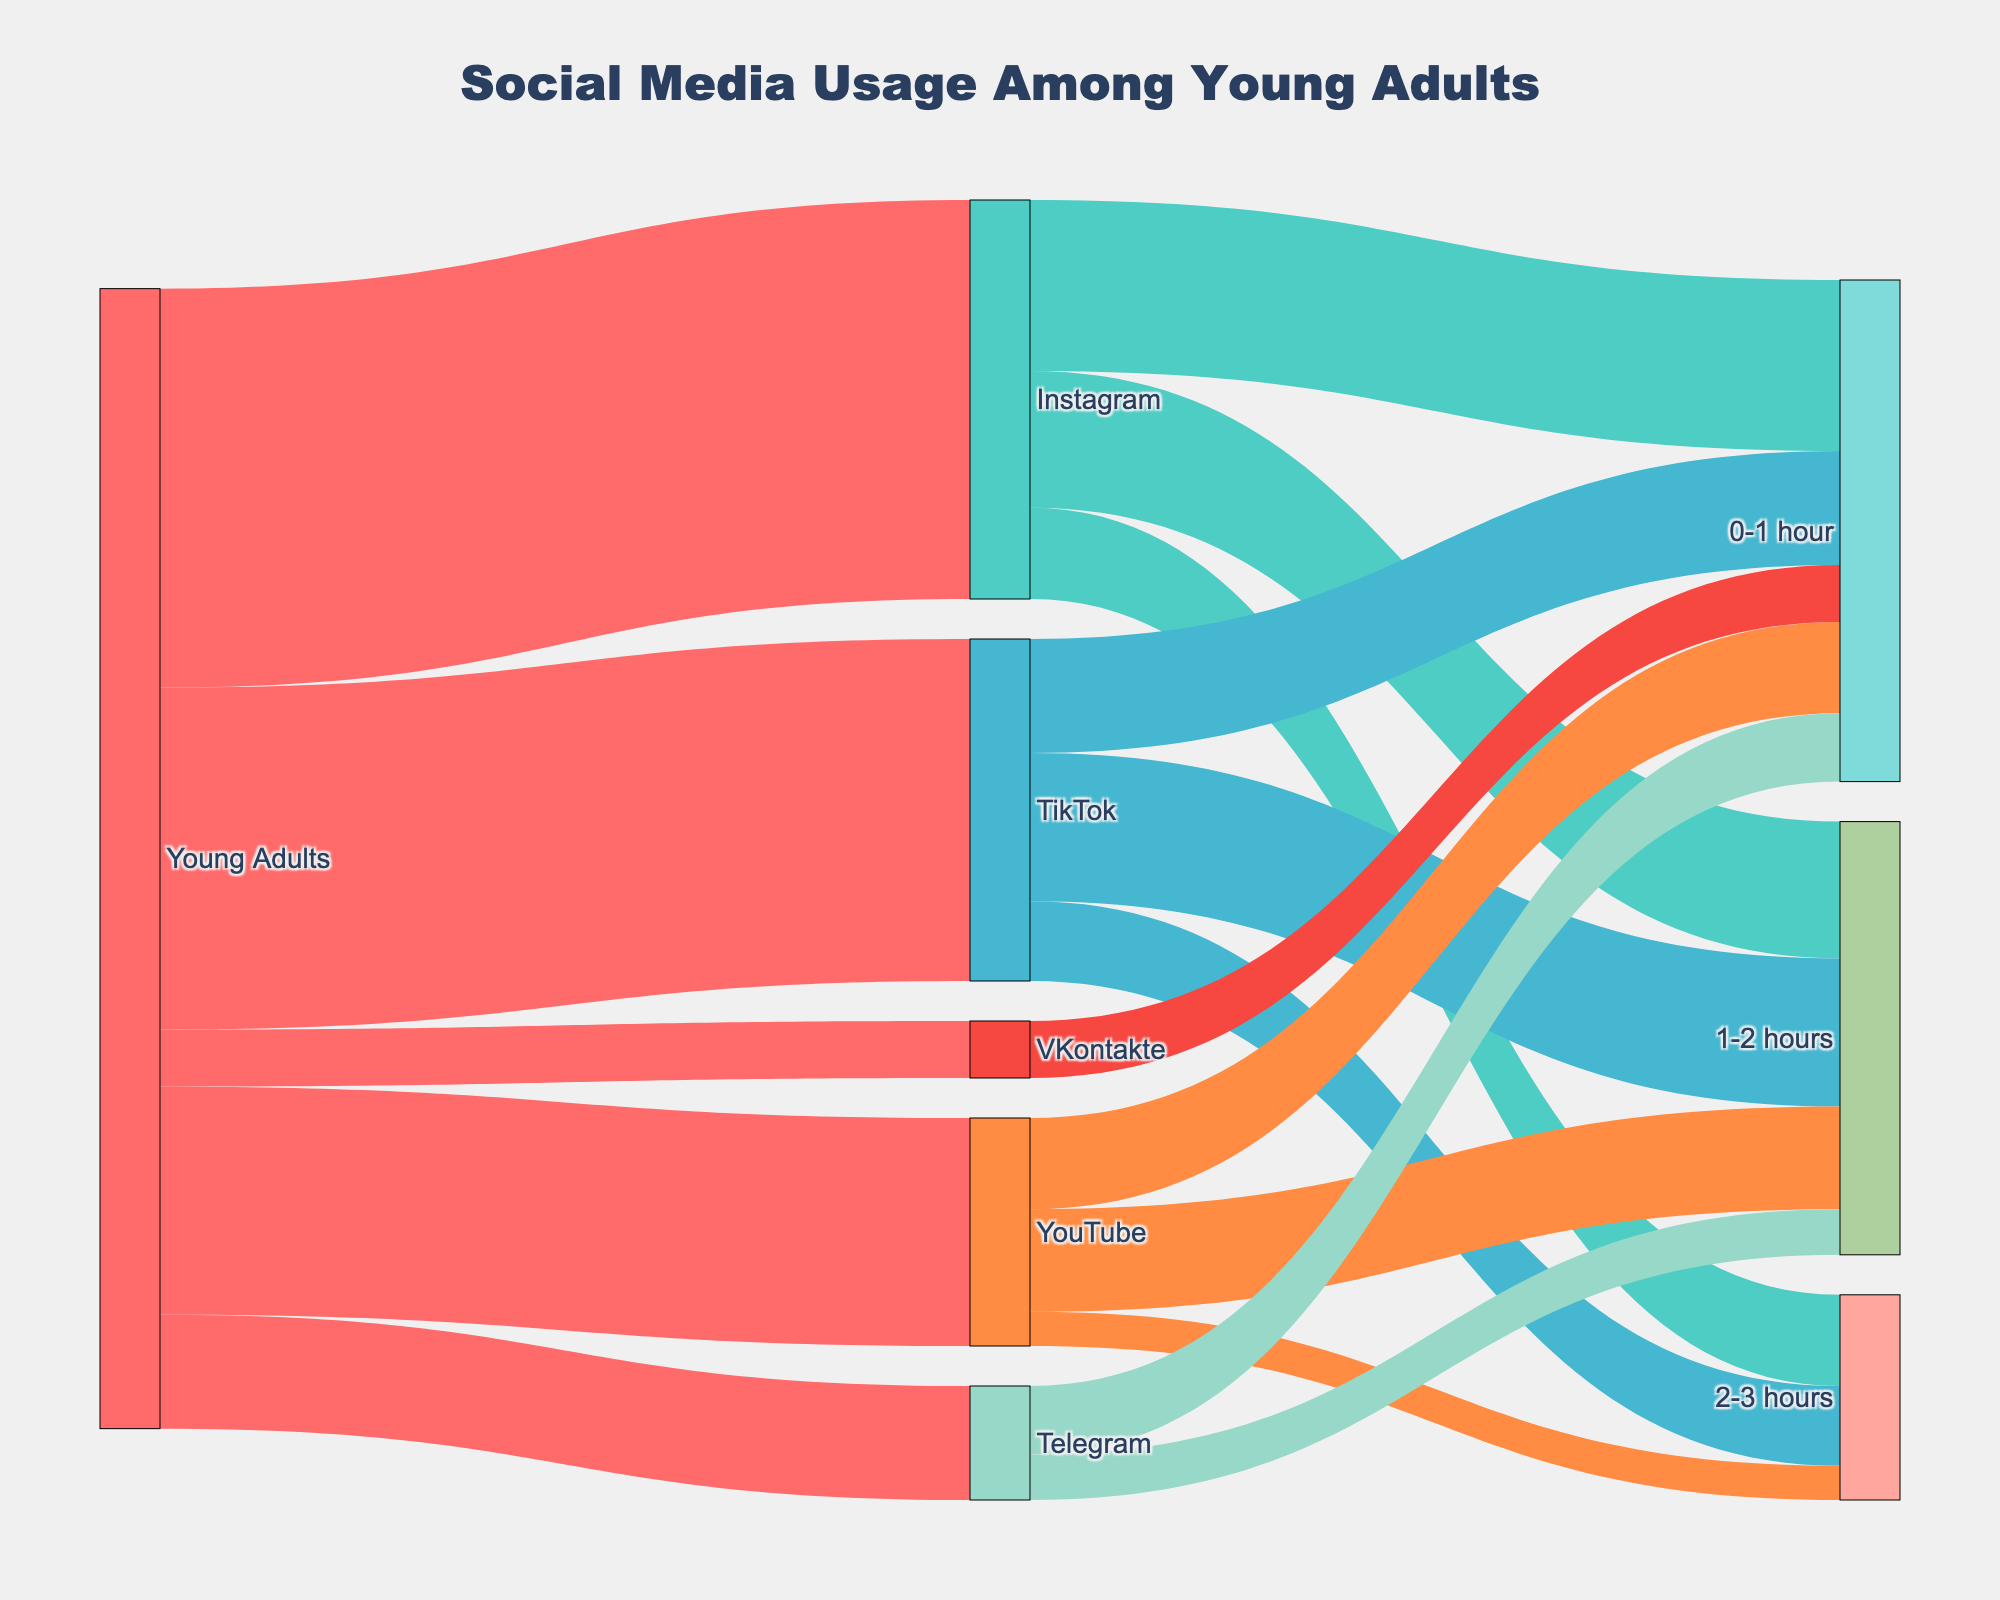What is the title of the diagram? The title is clearly displayed at the top of the figure. It reads "Social Media Usage Among Young Adults".
Answer: Social Media Usage Among Young Adults Which social media platform has the highest usage among young adults? By observing the width of the connections leading from "Young Adults" to each platform, Instagram has the thickest connection, representing the highest value of 35.
Answer: Instagram How many young adults use Telegram, according to the diagram? By looking at the link from "Young Adults" to "Telegram", it shows a value of 10.
Answer: 10 Among those who use TikTok, how many spend 1-2 hours on the platform? The link from "TikTok" to "1-2 hours" shows a value of 13.
Answer: 13 Which platform has the smallest number of users? By comparing the widths of the connections from "Young Adults" to each platform, VKontakte has the thinnest connection with a value of 5.
Answer: VKontakte What is the total number of young adults spending 0-1 hour across all platforms? Summing up all the "0-1 hour" links: Instagram (15), TikTok (10), YouTube (8), Telegram (6), VKontakte (5). The total is 15 + 10 + 8 + 6 + 5 = 44.
Answer: 44 How many young adults use YouTube and spend less than 1 hour on it? The link from "YouTube" to "0-1 hour" has a value of 8.
Answer: 8 Which social media platform has the most varied range of usage times (in hours)? By considering the number of hour categories (links) connected to each platform: Instagram has three ranges (0-1, 1-2, 2-3), projecting the most variety.
Answer: Instagram Compare the number of users who spend 2-3 hours on TikTok to those who spend 1-2 hours on Telegram. Which group is larger? TikTok's 2-3 hours has a link with value 7, while Telegram's 1-2 hours link has a value of 4. Therefore, the group spending 2-3 hours on TikTok is larger.
Answer: TikTok's 2-3 hours What percentage of Instagram users spend 1-2 hours on the platform? Instagram has a total of 35 users. 1-2 hours is 12. The percentage is (12/35) * 100 = 34.29%.
Answer: 34.29% 